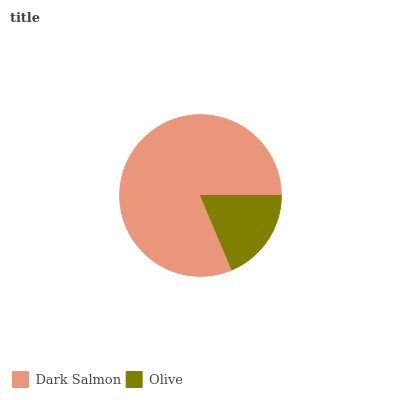Is Olive the minimum?
Answer yes or no. Yes. Is Dark Salmon the maximum?
Answer yes or no. Yes. Is Olive the maximum?
Answer yes or no. No. Is Dark Salmon greater than Olive?
Answer yes or no. Yes. Is Olive less than Dark Salmon?
Answer yes or no. Yes. Is Olive greater than Dark Salmon?
Answer yes or no. No. Is Dark Salmon less than Olive?
Answer yes or no. No. Is Dark Salmon the high median?
Answer yes or no. Yes. Is Olive the low median?
Answer yes or no. Yes. Is Olive the high median?
Answer yes or no. No. Is Dark Salmon the low median?
Answer yes or no. No. 